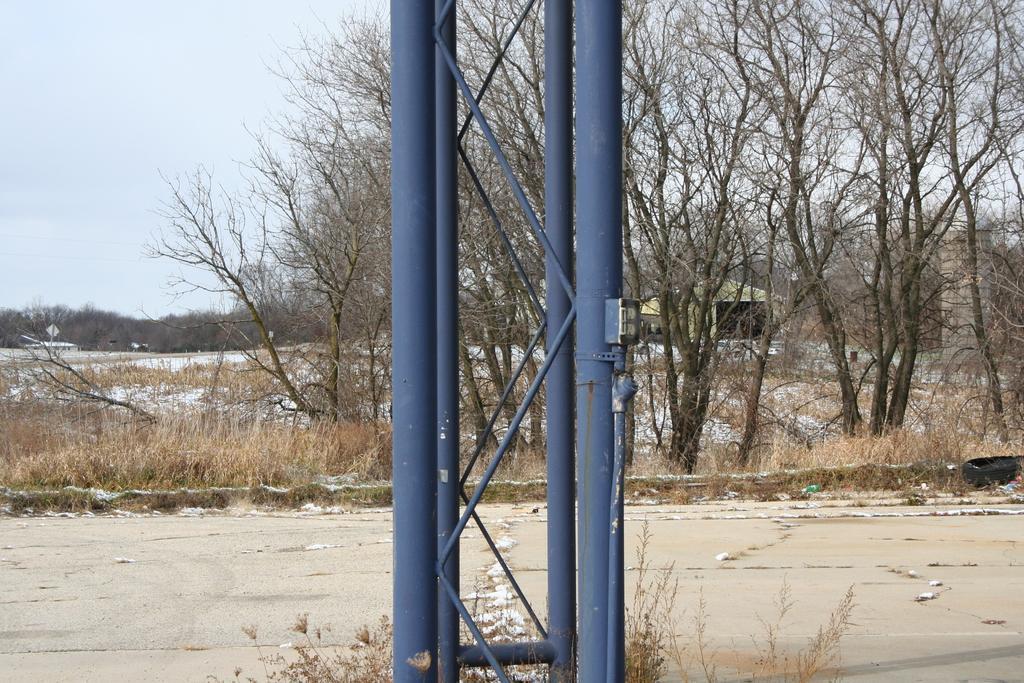Can you describe this image briefly? In this picture we can see a few poles and some plants on the path. We can see some dry grass from left to right. There are a few trees and a tent is visible at the back. It looks like a building on the right side. We can see some trees in the background. 